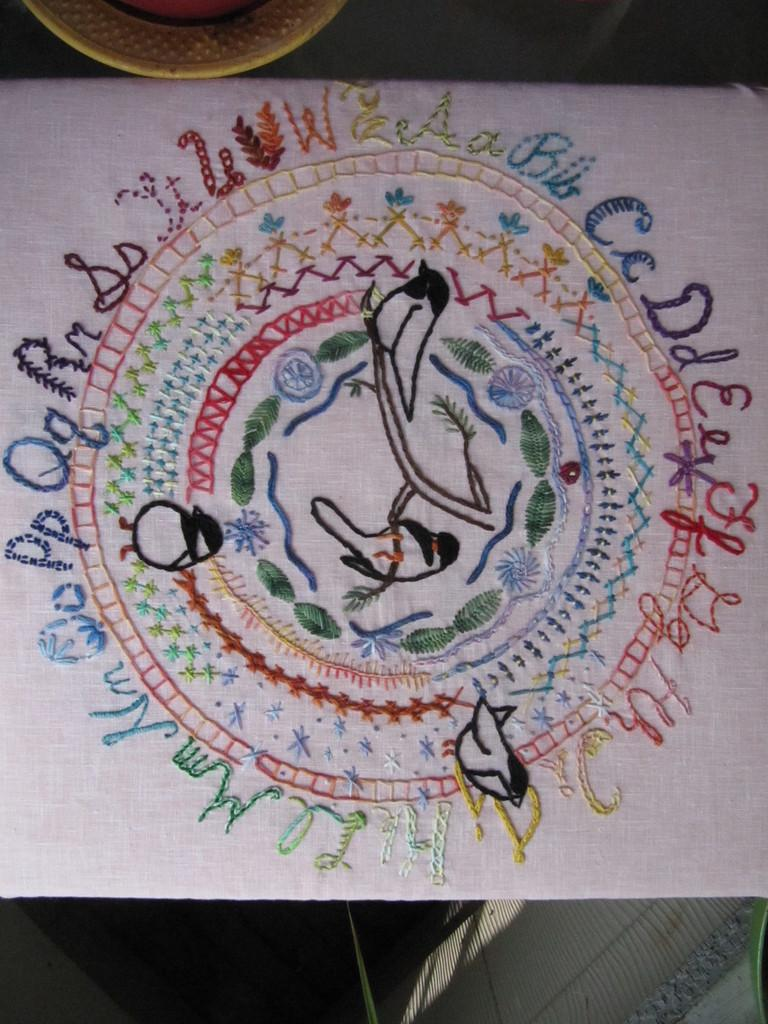What is the main subject of the image? The main subject of the image is a white cloth with an embroidery design. Can you describe the design on the cloth? Unfortunately, the facts provided do not give any details about the embroidery design. What else can be seen in the image besides the cloth? There is a small bowl in the image. What type of advertisement is being displayed on the hat in the image? There is no hat present in the image, so it is not possible to answer that question. 